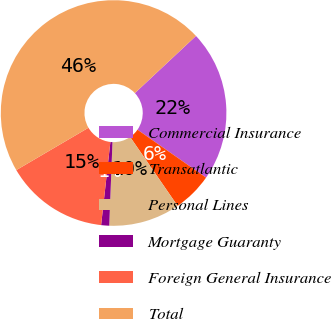<chart> <loc_0><loc_0><loc_500><loc_500><pie_chart><fcel>Commercial Insurance<fcel>Transatlantic<fcel>Personal Lines<fcel>Mortgage Guaranty<fcel>Foreign General Insurance<fcel>Total<nl><fcel>21.68%<fcel>5.69%<fcel>10.22%<fcel>1.15%<fcel>14.79%<fcel>46.48%<nl></chart> 